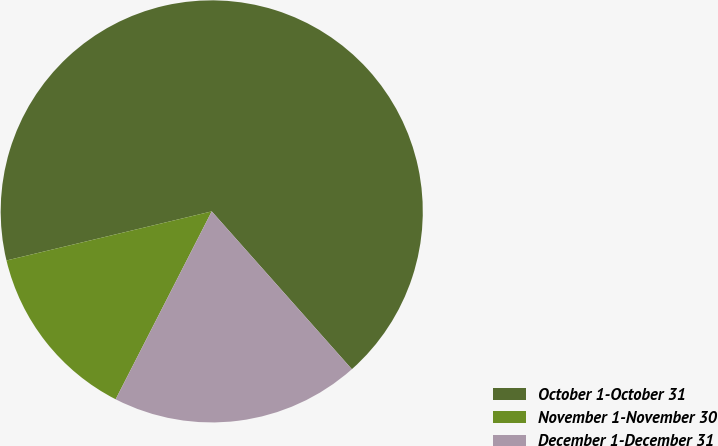<chart> <loc_0><loc_0><loc_500><loc_500><pie_chart><fcel>October 1-October 31<fcel>November 1-November 30<fcel>December 1-December 31<nl><fcel>67.18%<fcel>13.74%<fcel>19.08%<nl></chart> 